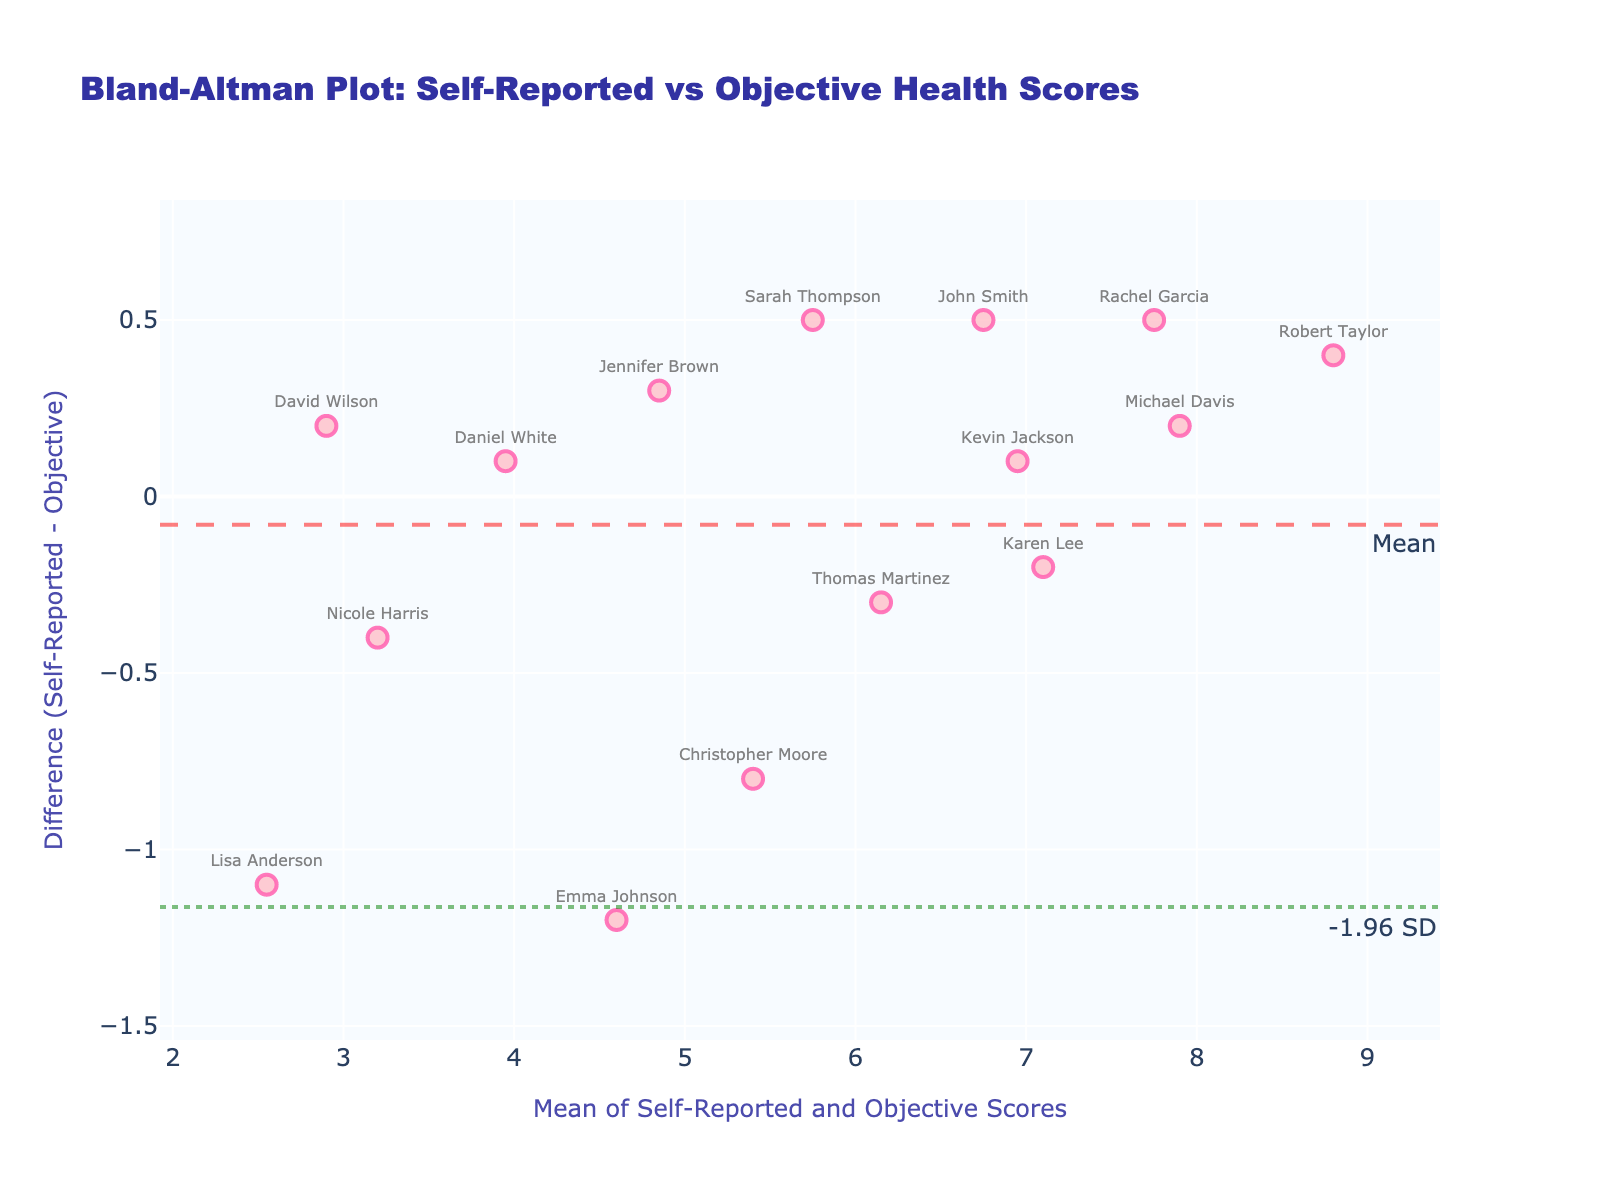Which patient has the smallest difference between self-reported and objective health scores? By looking at the y-values (difference) on the Bland-Altman plot, find the patient with a y-value closest to zero. This would be Thomas Martinez, as his difference is minimal visually.
Answer: Thomas Martinez What is the range of means between self-reported and objective health scores? To find the range, locate the smallest and largest values on the x-axis (mean values). The smallest mean is around 2.55 (Nicole Harris), and the largest mean is around 8.80 (Robert Taylor). Subtract the smallest mean from the largest mean to get the range: 8.80 - 2.55 = 6.25.
Answer: 6.25 How many patients reported a higher self-reported score compared to their objective score? Count the data points above the y = 0 line. These represent cases where the self-reported score is greater than the objective score. There are 7 such points.
Answer: 7 What are the upper and lower limits of agreement (LOA) in this plot? The upper limit of agreement (LOA) is marked by a horizontal dotted line annotated with "+1.96 SD," and the lower LOA is marked by another horizontal line annotated with "-1.96 SD." Visually, these appear at approximately +0.74 and -0.72, respectively.
Answer: +0.74 and -0.72 Which patient shows the largest positive difference (self-reported higher than objective)? Look for the highest data point above the mean difference line (y = 0). John Smith has the highest positive difference at around +0.5.
Answer: John Smith What is the average difference between self-reported and objective health scores? The mean difference is represented by a dashed line annotated as "Mean." The value is approximately zero.
Answer: 0 Are there any patients whose self-reported scores significantly deviate from their objective scores? Look for data points that lie beyond the upper or lower LOA lines. No patients fall significantly outside these limits.
Answer: No Which patient has a mean score closest to 5.5? By checking the x-axis values, Sarah Thompson has a mean score closest to 5.5.
Answer: Sarah Thompson 